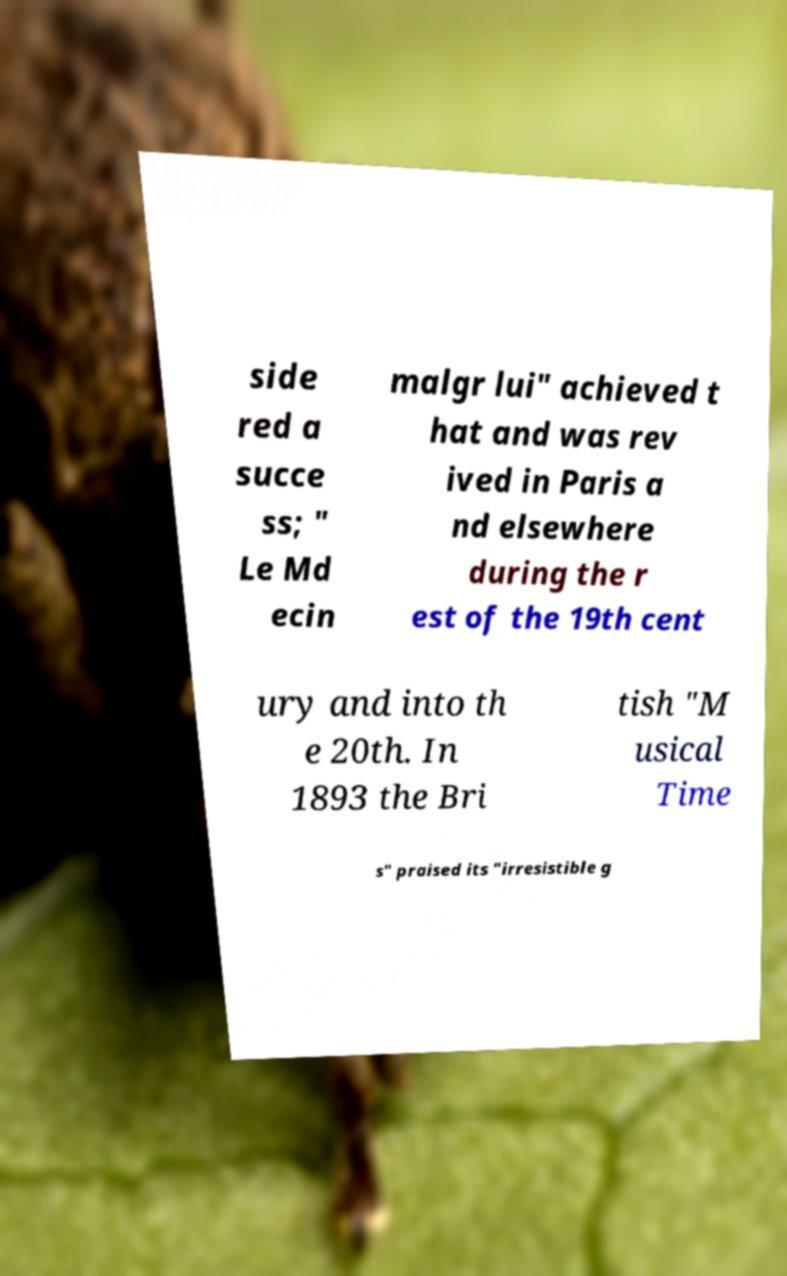Could you extract and type out the text from this image? side red a succe ss; " Le Md ecin malgr lui" achieved t hat and was rev ived in Paris a nd elsewhere during the r est of the 19th cent ury and into th e 20th. In 1893 the Bri tish "M usical Time s" praised its "irresistible g 